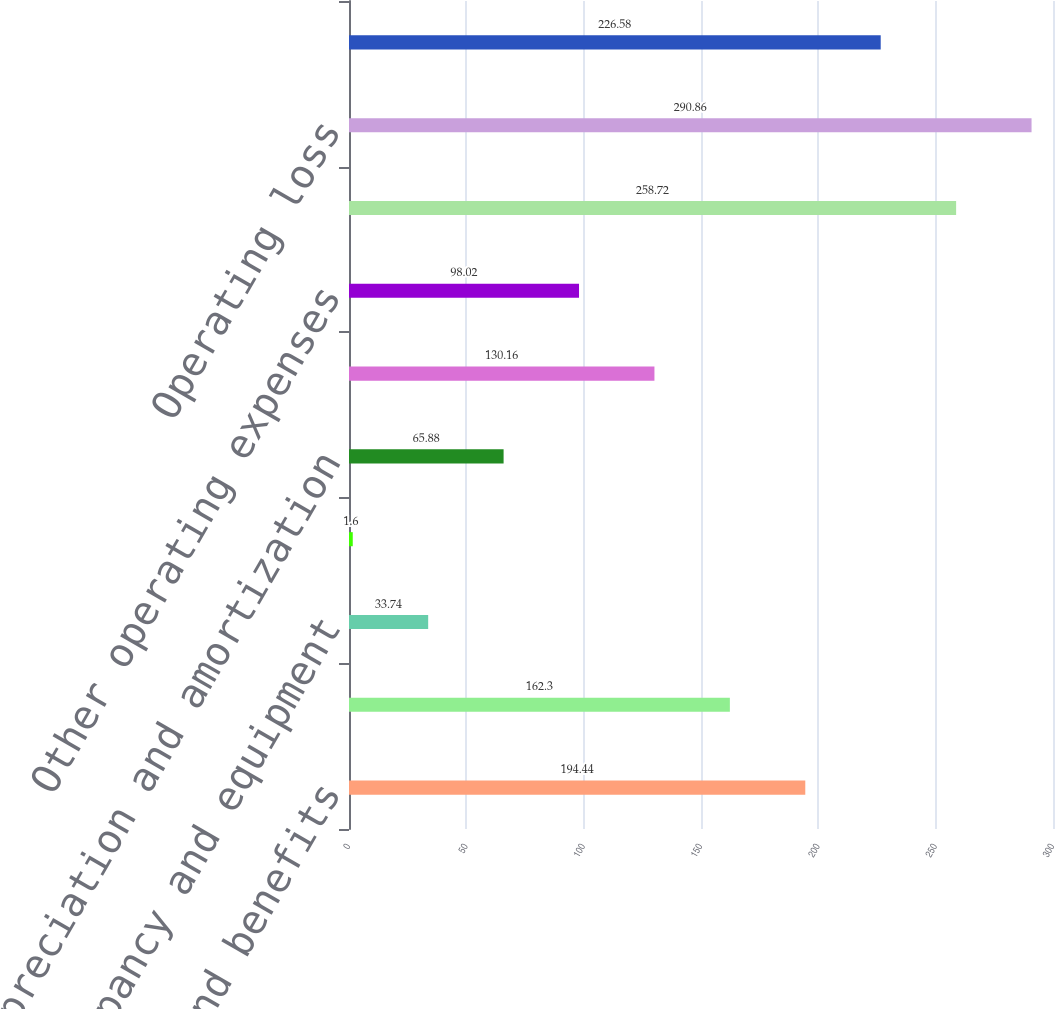<chart> <loc_0><loc_0><loc_500><loc_500><bar_chart><fcel>Compensation and benefits<fcel>Professional services<fcel>Occupancy and equipment<fcel>Communications<fcel>Depreciation and amortization<fcel>Facility restructuring and<fcel>Other operating expenses<fcel>Total operating expense<fcel>Operating loss<fcel>Total other income (expense)<nl><fcel>194.44<fcel>162.3<fcel>33.74<fcel>1.6<fcel>65.88<fcel>130.16<fcel>98.02<fcel>258.72<fcel>290.86<fcel>226.58<nl></chart> 